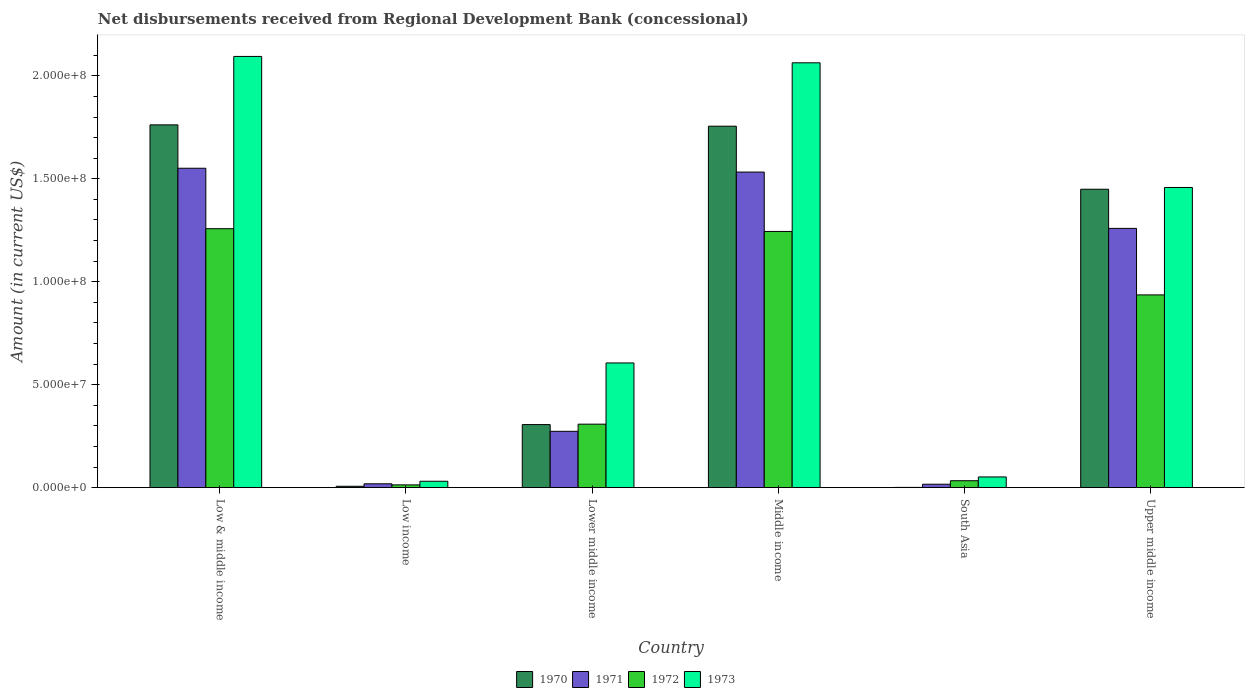How many different coloured bars are there?
Provide a succinct answer. 4. How many groups of bars are there?
Offer a very short reply. 6. How many bars are there on the 5th tick from the left?
Your response must be concise. 4. How many bars are there on the 3rd tick from the right?
Ensure brevity in your answer.  4. What is the label of the 3rd group of bars from the left?
Your answer should be compact. Lower middle income. What is the amount of disbursements received from Regional Development Bank in 1973 in Low & middle income?
Provide a short and direct response. 2.09e+08. Across all countries, what is the maximum amount of disbursements received from Regional Development Bank in 1972?
Ensure brevity in your answer.  1.26e+08. Across all countries, what is the minimum amount of disbursements received from Regional Development Bank in 1970?
Keep it short and to the point. 1.09e+05. In which country was the amount of disbursements received from Regional Development Bank in 1971 maximum?
Offer a terse response. Low & middle income. In which country was the amount of disbursements received from Regional Development Bank in 1973 minimum?
Make the answer very short. Low income. What is the total amount of disbursements received from Regional Development Bank in 1973 in the graph?
Your answer should be compact. 6.30e+08. What is the difference between the amount of disbursements received from Regional Development Bank in 1971 in Middle income and that in Upper middle income?
Keep it short and to the point. 2.74e+07. What is the difference between the amount of disbursements received from Regional Development Bank in 1971 in South Asia and the amount of disbursements received from Regional Development Bank in 1970 in Lower middle income?
Give a very brief answer. -2.90e+07. What is the average amount of disbursements received from Regional Development Bank in 1970 per country?
Offer a terse response. 8.80e+07. What is the difference between the amount of disbursements received from Regional Development Bank of/in 1972 and amount of disbursements received from Regional Development Bank of/in 1973 in Low income?
Your answer should be compact. -1.76e+06. What is the ratio of the amount of disbursements received from Regional Development Bank in 1971 in Lower middle income to that in Upper middle income?
Provide a succinct answer. 0.22. Is the amount of disbursements received from Regional Development Bank in 1970 in Low income less than that in Upper middle income?
Your response must be concise. Yes. What is the difference between the highest and the second highest amount of disbursements received from Regional Development Bank in 1971?
Ensure brevity in your answer.  1.86e+06. What is the difference between the highest and the lowest amount of disbursements received from Regional Development Bank in 1973?
Offer a terse response. 2.06e+08. Is the sum of the amount of disbursements received from Regional Development Bank in 1971 in Low & middle income and Low income greater than the maximum amount of disbursements received from Regional Development Bank in 1972 across all countries?
Give a very brief answer. Yes. Is it the case that in every country, the sum of the amount of disbursements received from Regional Development Bank in 1971 and amount of disbursements received from Regional Development Bank in 1970 is greater than the amount of disbursements received from Regional Development Bank in 1972?
Provide a short and direct response. No. How many bars are there?
Provide a succinct answer. 24. What is the difference between two consecutive major ticks on the Y-axis?
Your answer should be very brief. 5.00e+07. Are the values on the major ticks of Y-axis written in scientific E-notation?
Give a very brief answer. Yes. How are the legend labels stacked?
Your answer should be compact. Horizontal. What is the title of the graph?
Your response must be concise. Net disbursements received from Regional Development Bank (concessional). What is the label or title of the X-axis?
Offer a terse response. Country. What is the label or title of the Y-axis?
Your answer should be compact. Amount (in current US$). What is the Amount (in current US$) of 1970 in Low & middle income?
Ensure brevity in your answer.  1.76e+08. What is the Amount (in current US$) in 1971 in Low & middle income?
Provide a short and direct response. 1.55e+08. What is the Amount (in current US$) in 1972 in Low & middle income?
Offer a very short reply. 1.26e+08. What is the Amount (in current US$) of 1973 in Low & middle income?
Provide a succinct answer. 2.09e+08. What is the Amount (in current US$) in 1970 in Low income?
Ensure brevity in your answer.  6.47e+05. What is the Amount (in current US$) of 1971 in Low income?
Your answer should be compact. 1.86e+06. What is the Amount (in current US$) of 1972 in Low income?
Your response must be concise. 1.33e+06. What is the Amount (in current US$) of 1973 in Low income?
Offer a terse response. 3.09e+06. What is the Amount (in current US$) of 1970 in Lower middle income?
Provide a succinct answer. 3.06e+07. What is the Amount (in current US$) of 1971 in Lower middle income?
Keep it short and to the point. 2.74e+07. What is the Amount (in current US$) in 1972 in Lower middle income?
Give a very brief answer. 3.08e+07. What is the Amount (in current US$) of 1973 in Lower middle income?
Your answer should be very brief. 6.06e+07. What is the Amount (in current US$) in 1970 in Middle income?
Your answer should be compact. 1.76e+08. What is the Amount (in current US$) in 1971 in Middle income?
Provide a succinct answer. 1.53e+08. What is the Amount (in current US$) in 1972 in Middle income?
Provide a short and direct response. 1.24e+08. What is the Amount (in current US$) of 1973 in Middle income?
Your answer should be compact. 2.06e+08. What is the Amount (in current US$) in 1970 in South Asia?
Provide a short and direct response. 1.09e+05. What is the Amount (in current US$) in 1971 in South Asia?
Your answer should be very brief. 1.65e+06. What is the Amount (in current US$) of 1972 in South Asia?
Your answer should be compact. 3.35e+06. What is the Amount (in current US$) of 1973 in South Asia?
Your answer should be compact. 5.18e+06. What is the Amount (in current US$) in 1970 in Upper middle income?
Your response must be concise. 1.45e+08. What is the Amount (in current US$) in 1971 in Upper middle income?
Ensure brevity in your answer.  1.26e+08. What is the Amount (in current US$) of 1972 in Upper middle income?
Your response must be concise. 9.36e+07. What is the Amount (in current US$) in 1973 in Upper middle income?
Provide a short and direct response. 1.46e+08. Across all countries, what is the maximum Amount (in current US$) in 1970?
Keep it short and to the point. 1.76e+08. Across all countries, what is the maximum Amount (in current US$) of 1971?
Your answer should be compact. 1.55e+08. Across all countries, what is the maximum Amount (in current US$) of 1972?
Your answer should be very brief. 1.26e+08. Across all countries, what is the maximum Amount (in current US$) in 1973?
Ensure brevity in your answer.  2.09e+08. Across all countries, what is the minimum Amount (in current US$) in 1970?
Your response must be concise. 1.09e+05. Across all countries, what is the minimum Amount (in current US$) of 1971?
Offer a very short reply. 1.65e+06. Across all countries, what is the minimum Amount (in current US$) of 1972?
Give a very brief answer. 1.33e+06. Across all countries, what is the minimum Amount (in current US$) in 1973?
Provide a succinct answer. 3.09e+06. What is the total Amount (in current US$) of 1970 in the graph?
Keep it short and to the point. 5.28e+08. What is the total Amount (in current US$) in 1971 in the graph?
Provide a short and direct response. 4.65e+08. What is the total Amount (in current US$) of 1972 in the graph?
Provide a succinct answer. 3.79e+08. What is the total Amount (in current US$) of 1973 in the graph?
Ensure brevity in your answer.  6.30e+08. What is the difference between the Amount (in current US$) in 1970 in Low & middle income and that in Low income?
Ensure brevity in your answer.  1.76e+08. What is the difference between the Amount (in current US$) in 1971 in Low & middle income and that in Low income?
Your answer should be compact. 1.53e+08. What is the difference between the Amount (in current US$) of 1972 in Low & middle income and that in Low income?
Keep it short and to the point. 1.24e+08. What is the difference between the Amount (in current US$) of 1973 in Low & middle income and that in Low income?
Your response must be concise. 2.06e+08. What is the difference between the Amount (in current US$) in 1970 in Low & middle income and that in Lower middle income?
Your response must be concise. 1.46e+08. What is the difference between the Amount (in current US$) of 1971 in Low & middle income and that in Lower middle income?
Keep it short and to the point. 1.28e+08. What is the difference between the Amount (in current US$) of 1972 in Low & middle income and that in Lower middle income?
Your answer should be very brief. 9.49e+07. What is the difference between the Amount (in current US$) in 1973 in Low & middle income and that in Lower middle income?
Your answer should be very brief. 1.49e+08. What is the difference between the Amount (in current US$) in 1970 in Low & middle income and that in Middle income?
Offer a terse response. 6.47e+05. What is the difference between the Amount (in current US$) of 1971 in Low & middle income and that in Middle income?
Your answer should be compact. 1.86e+06. What is the difference between the Amount (in current US$) in 1972 in Low & middle income and that in Middle income?
Provide a short and direct response. 1.33e+06. What is the difference between the Amount (in current US$) of 1973 in Low & middle income and that in Middle income?
Make the answer very short. 3.09e+06. What is the difference between the Amount (in current US$) in 1970 in Low & middle income and that in South Asia?
Give a very brief answer. 1.76e+08. What is the difference between the Amount (in current US$) in 1971 in Low & middle income and that in South Asia?
Provide a short and direct response. 1.53e+08. What is the difference between the Amount (in current US$) in 1972 in Low & middle income and that in South Asia?
Your answer should be compact. 1.22e+08. What is the difference between the Amount (in current US$) in 1973 in Low & middle income and that in South Asia?
Your answer should be very brief. 2.04e+08. What is the difference between the Amount (in current US$) in 1970 in Low & middle income and that in Upper middle income?
Provide a succinct answer. 3.13e+07. What is the difference between the Amount (in current US$) in 1971 in Low & middle income and that in Upper middle income?
Give a very brief answer. 2.92e+07. What is the difference between the Amount (in current US$) in 1972 in Low & middle income and that in Upper middle income?
Your response must be concise. 3.22e+07. What is the difference between the Amount (in current US$) of 1973 in Low & middle income and that in Upper middle income?
Ensure brevity in your answer.  6.36e+07. What is the difference between the Amount (in current US$) of 1970 in Low income and that in Lower middle income?
Offer a terse response. -3.00e+07. What is the difference between the Amount (in current US$) in 1971 in Low income and that in Lower middle income?
Provide a succinct answer. -2.55e+07. What is the difference between the Amount (in current US$) in 1972 in Low income and that in Lower middle income?
Provide a succinct answer. -2.95e+07. What is the difference between the Amount (in current US$) of 1973 in Low income and that in Lower middle income?
Give a very brief answer. -5.75e+07. What is the difference between the Amount (in current US$) in 1970 in Low income and that in Middle income?
Make the answer very short. -1.75e+08. What is the difference between the Amount (in current US$) in 1971 in Low income and that in Middle income?
Keep it short and to the point. -1.51e+08. What is the difference between the Amount (in current US$) of 1972 in Low income and that in Middle income?
Give a very brief answer. -1.23e+08. What is the difference between the Amount (in current US$) in 1973 in Low income and that in Middle income?
Offer a very short reply. -2.03e+08. What is the difference between the Amount (in current US$) in 1970 in Low income and that in South Asia?
Offer a very short reply. 5.38e+05. What is the difference between the Amount (in current US$) in 1971 in Low income and that in South Asia?
Provide a succinct answer. 2.09e+05. What is the difference between the Amount (in current US$) in 1972 in Low income and that in South Asia?
Your answer should be compact. -2.02e+06. What is the difference between the Amount (in current US$) of 1973 in Low income and that in South Asia?
Offer a very short reply. -2.09e+06. What is the difference between the Amount (in current US$) of 1970 in Low income and that in Upper middle income?
Offer a terse response. -1.44e+08. What is the difference between the Amount (in current US$) of 1971 in Low income and that in Upper middle income?
Provide a short and direct response. -1.24e+08. What is the difference between the Amount (in current US$) in 1972 in Low income and that in Upper middle income?
Offer a very short reply. -9.23e+07. What is the difference between the Amount (in current US$) of 1973 in Low income and that in Upper middle income?
Provide a succinct answer. -1.43e+08. What is the difference between the Amount (in current US$) in 1970 in Lower middle income and that in Middle income?
Provide a short and direct response. -1.45e+08. What is the difference between the Amount (in current US$) in 1971 in Lower middle income and that in Middle income?
Your answer should be compact. -1.26e+08. What is the difference between the Amount (in current US$) of 1972 in Lower middle income and that in Middle income?
Offer a very short reply. -9.36e+07. What is the difference between the Amount (in current US$) in 1973 in Lower middle income and that in Middle income?
Offer a very short reply. -1.46e+08. What is the difference between the Amount (in current US$) of 1970 in Lower middle income and that in South Asia?
Offer a very short reply. 3.05e+07. What is the difference between the Amount (in current US$) in 1971 in Lower middle income and that in South Asia?
Your answer should be very brief. 2.57e+07. What is the difference between the Amount (in current US$) in 1972 in Lower middle income and that in South Asia?
Your answer should be compact. 2.75e+07. What is the difference between the Amount (in current US$) of 1973 in Lower middle income and that in South Asia?
Make the answer very short. 5.54e+07. What is the difference between the Amount (in current US$) in 1970 in Lower middle income and that in Upper middle income?
Offer a terse response. -1.14e+08. What is the difference between the Amount (in current US$) in 1971 in Lower middle income and that in Upper middle income?
Your answer should be compact. -9.86e+07. What is the difference between the Amount (in current US$) of 1972 in Lower middle income and that in Upper middle income?
Keep it short and to the point. -6.28e+07. What is the difference between the Amount (in current US$) in 1973 in Lower middle income and that in Upper middle income?
Your response must be concise. -8.52e+07. What is the difference between the Amount (in current US$) in 1970 in Middle income and that in South Asia?
Ensure brevity in your answer.  1.75e+08. What is the difference between the Amount (in current US$) in 1971 in Middle income and that in South Asia?
Your answer should be compact. 1.52e+08. What is the difference between the Amount (in current US$) in 1972 in Middle income and that in South Asia?
Your response must be concise. 1.21e+08. What is the difference between the Amount (in current US$) of 1973 in Middle income and that in South Asia?
Your response must be concise. 2.01e+08. What is the difference between the Amount (in current US$) in 1970 in Middle income and that in Upper middle income?
Provide a succinct answer. 3.06e+07. What is the difference between the Amount (in current US$) of 1971 in Middle income and that in Upper middle income?
Provide a short and direct response. 2.74e+07. What is the difference between the Amount (in current US$) of 1972 in Middle income and that in Upper middle income?
Your answer should be compact. 3.08e+07. What is the difference between the Amount (in current US$) of 1973 in Middle income and that in Upper middle income?
Your answer should be very brief. 6.06e+07. What is the difference between the Amount (in current US$) in 1970 in South Asia and that in Upper middle income?
Your response must be concise. -1.45e+08. What is the difference between the Amount (in current US$) of 1971 in South Asia and that in Upper middle income?
Provide a succinct answer. -1.24e+08. What is the difference between the Amount (in current US$) of 1972 in South Asia and that in Upper middle income?
Your response must be concise. -9.03e+07. What is the difference between the Amount (in current US$) of 1973 in South Asia and that in Upper middle income?
Keep it short and to the point. -1.41e+08. What is the difference between the Amount (in current US$) in 1970 in Low & middle income and the Amount (in current US$) in 1971 in Low income?
Provide a succinct answer. 1.74e+08. What is the difference between the Amount (in current US$) in 1970 in Low & middle income and the Amount (in current US$) in 1972 in Low income?
Provide a short and direct response. 1.75e+08. What is the difference between the Amount (in current US$) of 1970 in Low & middle income and the Amount (in current US$) of 1973 in Low income?
Keep it short and to the point. 1.73e+08. What is the difference between the Amount (in current US$) of 1971 in Low & middle income and the Amount (in current US$) of 1972 in Low income?
Your response must be concise. 1.54e+08. What is the difference between the Amount (in current US$) in 1971 in Low & middle income and the Amount (in current US$) in 1973 in Low income?
Provide a short and direct response. 1.52e+08. What is the difference between the Amount (in current US$) of 1972 in Low & middle income and the Amount (in current US$) of 1973 in Low income?
Provide a succinct answer. 1.23e+08. What is the difference between the Amount (in current US$) in 1970 in Low & middle income and the Amount (in current US$) in 1971 in Lower middle income?
Your response must be concise. 1.49e+08. What is the difference between the Amount (in current US$) of 1970 in Low & middle income and the Amount (in current US$) of 1972 in Lower middle income?
Provide a short and direct response. 1.45e+08. What is the difference between the Amount (in current US$) of 1970 in Low & middle income and the Amount (in current US$) of 1973 in Lower middle income?
Make the answer very short. 1.16e+08. What is the difference between the Amount (in current US$) in 1971 in Low & middle income and the Amount (in current US$) in 1972 in Lower middle income?
Offer a terse response. 1.24e+08. What is the difference between the Amount (in current US$) of 1971 in Low & middle income and the Amount (in current US$) of 1973 in Lower middle income?
Offer a terse response. 9.46e+07. What is the difference between the Amount (in current US$) in 1972 in Low & middle income and the Amount (in current US$) in 1973 in Lower middle income?
Ensure brevity in your answer.  6.52e+07. What is the difference between the Amount (in current US$) in 1970 in Low & middle income and the Amount (in current US$) in 1971 in Middle income?
Ensure brevity in your answer.  2.29e+07. What is the difference between the Amount (in current US$) of 1970 in Low & middle income and the Amount (in current US$) of 1972 in Middle income?
Your answer should be very brief. 5.18e+07. What is the difference between the Amount (in current US$) of 1970 in Low & middle income and the Amount (in current US$) of 1973 in Middle income?
Your answer should be very brief. -3.01e+07. What is the difference between the Amount (in current US$) in 1971 in Low & middle income and the Amount (in current US$) in 1972 in Middle income?
Offer a terse response. 3.07e+07. What is the difference between the Amount (in current US$) of 1971 in Low & middle income and the Amount (in current US$) of 1973 in Middle income?
Your response must be concise. -5.12e+07. What is the difference between the Amount (in current US$) in 1972 in Low & middle income and the Amount (in current US$) in 1973 in Middle income?
Your answer should be very brief. -8.06e+07. What is the difference between the Amount (in current US$) in 1970 in Low & middle income and the Amount (in current US$) in 1971 in South Asia?
Ensure brevity in your answer.  1.75e+08. What is the difference between the Amount (in current US$) of 1970 in Low & middle income and the Amount (in current US$) of 1972 in South Asia?
Your answer should be compact. 1.73e+08. What is the difference between the Amount (in current US$) in 1970 in Low & middle income and the Amount (in current US$) in 1973 in South Asia?
Your answer should be very brief. 1.71e+08. What is the difference between the Amount (in current US$) of 1971 in Low & middle income and the Amount (in current US$) of 1972 in South Asia?
Give a very brief answer. 1.52e+08. What is the difference between the Amount (in current US$) of 1971 in Low & middle income and the Amount (in current US$) of 1973 in South Asia?
Provide a short and direct response. 1.50e+08. What is the difference between the Amount (in current US$) in 1972 in Low & middle income and the Amount (in current US$) in 1973 in South Asia?
Provide a succinct answer. 1.21e+08. What is the difference between the Amount (in current US$) of 1970 in Low & middle income and the Amount (in current US$) of 1971 in Upper middle income?
Ensure brevity in your answer.  5.03e+07. What is the difference between the Amount (in current US$) of 1970 in Low & middle income and the Amount (in current US$) of 1972 in Upper middle income?
Offer a terse response. 8.26e+07. What is the difference between the Amount (in current US$) of 1970 in Low & middle income and the Amount (in current US$) of 1973 in Upper middle income?
Give a very brief answer. 3.04e+07. What is the difference between the Amount (in current US$) in 1971 in Low & middle income and the Amount (in current US$) in 1972 in Upper middle income?
Keep it short and to the point. 6.15e+07. What is the difference between the Amount (in current US$) of 1971 in Low & middle income and the Amount (in current US$) of 1973 in Upper middle income?
Your response must be concise. 9.34e+06. What is the difference between the Amount (in current US$) of 1972 in Low & middle income and the Amount (in current US$) of 1973 in Upper middle income?
Give a very brief answer. -2.00e+07. What is the difference between the Amount (in current US$) in 1970 in Low income and the Amount (in current US$) in 1971 in Lower middle income?
Your answer should be very brief. -2.67e+07. What is the difference between the Amount (in current US$) of 1970 in Low income and the Amount (in current US$) of 1972 in Lower middle income?
Make the answer very short. -3.02e+07. What is the difference between the Amount (in current US$) of 1970 in Low income and the Amount (in current US$) of 1973 in Lower middle income?
Offer a terse response. -5.99e+07. What is the difference between the Amount (in current US$) in 1971 in Low income and the Amount (in current US$) in 1972 in Lower middle income?
Your response must be concise. -2.90e+07. What is the difference between the Amount (in current US$) of 1971 in Low income and the Amount (in current US$) of 1973 in Lower middle income?
Give a very brief answer. -5.87e+07. What is the difference between the Amount (in current US$) in 1972 in Low income and the Amount (in current US$) in 1973 in Lower middle income?
Your answer should be compact. -5.92e+07. What is the difference between the Amount (in current US$) of 1970 in Low income and the Amount (in current US$) of 1971 in Middle income?
Give a very brief answer. -1.53e+08. What is the difference between the Amount (in current US$) of 1970 in Low income and the Amount (in current US$) of 1972 in Middle income?
Give a very brief answer. -1.24e+08. What is the difference between the Amount (in current US$) in 1970 in Low income and the Amount (in current US$) in 1973 in Middle income?
Provide a short and direct response. -2.06e+08. What is the difference between the Amount (in current US$) of 1971 in Low income and the Amount (in current US$) of 1972 in Middle income?
Keep it short and to the point. -1.23e+08. What is the difference between the Amount (in current US$) in 1971 in Low income and the Amount (in current US$) in 1973 in Middle income?
Your response must be concise. -2.04e+08. What is the difference between the Amount (in current US$) in 1972 in Low income and the Amount (in current US$) in 1973 in Middle income?
Make the answer very short. -2.05e+08. What is the difference between the Amount (in current US$) of 1970 in Low income and the Amount (in current US$) of 1971 in South Asia?
Your response must be concise. -1.00e+06. What is the difference between the Amount (in current US$) in 1970 in Low income and the Amount (in current US$) in 1972 in South Asia?
Your response must be concise. -2.70e+06. What is the difference between the Amount (in current US$) of 1970 in Low income and the Amount (in current US$) of 1973 in South Asia?
Provide a short and direct response. -4.54e+06. What is the difference between the Amount (in current US$) in 1971 in Low income and the Amount (in current US$) in 1972 in South Asia?
Give a very brief answer. -1.49e+06. What is the difference between the Amount (in current US$) of 1971 in Low income and the Amount (in current US$) of 1973 in South Asia?
Offer a very short reply. -3.32e+06. What is the difference between the Amount (in current US$) in 1972 in Low income and the Amount (in current US$) in 1973 in South Asia?
Provide a short and direct response. -3.85e+06. What is the difference between the Amount (in current US$) in 1970 in Low income and the Amount (in current US$) in 1971 in Upper middle income?
Your response must be concise. -1.25e+08. What is the difference between the Amount (in current US$) in 1970 in Low income and the Amount (in current US$) in 1972 in Upper middle income?
Provide a short and direct response. -9.30e+07. What is the difference between the Amount (in current US$) in 1970 in Low income and the Amount (in current US$) in 1973 in Upper middle income?
Offer a terse response. -1.45e+08. What is the difference between the Amount (in current US$) of 1971 in Low income and the Amount (in current US$) of 1972 in Upper middle income?
Ensure brevity in your answer.  -9.17e+07. What is the difference between the Amount (in current US$) of 1971 in Low income and the Amount (in current US$) of 1973 in Upper middle income?
Keep it short and to the point. -1.44e+08. What is the difference between the Amount (in current US$) in 1972 in Low income and the Amount (in current US$) in 1973 in Upper middle income?
Offer a terse response. -1.44e+08. What is the difference between the Amount (in current US$) in 1970 in Lower middle income and the Amount (in current US$) in 1971 in Middle income?
Provide a succinct answer. -1.23e+08. What is the difference between the Amount (in current US$) of 1970 in Lower middle income and the Amount (in current US$) of 1972 in Middle income?
Your answer should be very brief. -9.38e+07. What is the difference between the Amount (in current US$) of 1970 in Lower middle income and the Amount (in current US$) of 1973 in Middle income?
Keep it short and to the point. -1.76e+08. What is the difference between the Amount (in current US$) of 1971 in Lower middle income and the Amount (in current US$) of 1972 in Middle income?
Offer a terse response. -9.71e+07. What is the difference between the Amount (in current US$) in 1971 in Lower middle income and the Amount (in current US$) in 1973 in Middle income?
Give a very brief answer. -1.79e+08. What is the difference between the Amount (in current US$) of 1972 in Lower middle income and the Amount (in current US$) of 1973 in Middle income?
Keep it short and to the point. -1.76e+08. What is the difference between the Amount (in current US$) of 1970 in Lower middle income and the Amount (in current US$) of 1971 in South Asia?
Your answer should be very brief. 2.90e+07. What is the difference between the Amount (in current US$) of 1970 in Lower middle income and the Amount (in current US$) of 1972 in South Asia?
Give a very brief answer. 2.73e+07. What is the difference between the Amount (in current US$) of 1970 in Lower middle income and the Amount (in current US$) of 1973 in South Asia?
Your response must be concise. 2.54e+07. What is the difference between the Amount (in current US$) in 1971 in Lower middle income and the Amount (in current US$) in 1972 in South Asia?
Offer a terse response. 2.40e+07. What is the difference between the Amount (in current US$) of 1971 in Lower middle income and the Amount (in current US$) of 1973 in South Asia?
Keep it short and to the point. 2.22e+07. What is the difference between the Amount (in current US$) of 1972 in Lower middle income and the Amount (in current US$) of 1973 in South Asia?
Offer a very short reply. 2.56e+07. What is the difference between the Amount (in current US$) in 1970 in Lower middle income and the Amount (in current US$) in 1971 in Upper middle income?
Provide a succinct answer. -9.53e+07. What is the difference between the Amount (in current US$) of 1970 in Lower middle income and the Amount (in current US$) of 1972 in Upper middle income?
Keep it short and to the point. -6.30e+07. What is the difference between the Amount (in current US$) of 1970 in Lower middle income and the Amount (in current US$) of 1973 in Upper middle income?
Give a very brief answer. -1.15e+08. What is the difference between the Amount (in current US$) in 1971 in Lower middle income and the Amount (in current US$) in 1972 in Upper middle income?
Your response must be concise. -6.63e+07. What is the difference between the Amount (in current US$) of 1971 in Lower middle income and the Amount (in current US$) of 1973 in Upper middle income?
Ensure brevity in your answer.  -1.18e+08. What is the difference between the Amount (in current US$) of 1972 in Lower middle income and the Amount (in current US$) of 1973 in Upper middle income?
Keep it short and to the point. -1.15e+08. What is the difference between the Amount (in current US$) in 1970 in Middle income and the Amount (in current US$) in 1971 in South Asia?
Keep it short and to the point. 1.74e+08. What is the difference between the Amount (in current US$) of 1970 in Middle income and the Amount (in current US$) of 1972 in South Asia?
Make the answer very short. 1.72e+08. What is the difference between the Amount (in current US$) of 1970 in Middle income and the Amount (in current US$) of 1973 in South Asia?
Your answer should be very brief. 1.70e+08. What is the difference between the Amount (in current US$) of 1971 in Middle income and the Amount (in current US$) of 1972 in South Asia?
Ensure brevity in your answer.  1.50e+08. What is the difference between the Amount (in current US$) in 1971 in Middle income and the Amount (in current US$) in 1973 in South Asia?
Keep it short and to the point. 1.48e+08. What is the difference between the Amount (in current US$) in 1972 in Middle income and the Amount (in current US$) in 1973 in South Asia?
Your answer should be compact. 1.19e+08. What is the difference between the Amount (in current US$) in 1970 in Middle income and the Amount (in current US$) in 1971 in Upper middle income?
Provide a succinct answer. 4.96e+07. What is the difference between the Amount (in current US$) of 1970 in Middle income and the Amount (in current US$) of 1972 in Upper middle income?
Offer a terse response. 8.19e+07. What is the difference between the Amount (in current US$) of 1970 in Middle income and the Amount (in current US$) of 1973 in Upper middle income?
Provide a succinct answer. 2.98e+07. What is the difference between the Amount (in current US$) in 1971 in Middle income and the Amount (in current US$) in 1972 in Upper middle income?
Provide a succinct answer. 5.97e+07. What is the difference between the Amount (in current US$) of 1971 in Middle income and the Amount (in current US$) of 1973 in Upper middle income?
Offer a terse response. 7.49e+06. What is the difference between the Amount (in current US$) in 1972 in Middle income and the Amount (in current US$) in 1973 in Upper middle income?
Ensure brevity in your answer.  -2.14e+07. What is the difference between the Amount (in current US$) in 1970 in South Asia and the Amount (in current US$) in 1971 in Upper middle income?
Offer a terse response. -1.26e+08. What is the difference between the Amount (in current US$) of 1970 in South Asia and the Amount (in current US$) of 1972 in Upper middle income?
Your response must be concise. -9.35e+07. What is the difference between the Amount (in current US$) in 1970 in South Asia and the Amount (in current US$) in 1973 in Upper middle income?
Offer a very short reply. -1.46e+08. What is the difference between the Amount (in current US$) in 1971 in South Asia and the Amount (in current US$) in 1972 in Upper middle income?
Make the answer very short. -9.20e+07. What is the difference between the Amount (in current US$) in 1971 in South Asia and the Amount (in current US$) in 1973 in Upper middle income?
Your answer should be very brief. -1.44e+08. What is the difference between the Amount (in current US$) of 1972 in South Asia and the Amount (in current US$) of 1973 in Upper middle income?
Provide a short and direct response. -1.42e+08. What is the average Amount (in current US$) of 1970 per country?
Ensure brevity in your answer.  8.80e+07. What is the average Amount (in current US$) in 1971 per country?
Keep it short and to the point. 7.75e+07. What is the average Amount (in current US$) of 1972 per country?
Your answer should be compact. 6.32e+07. What is the average Amount (in current US$) in 1973 per country?
Offer a terse response. 1.05e+08. What is the difference between the Amount (in current US$) in 1970 and Amount (in current US$) in 1971 in Low & middle income?
Give a very brief answer. 2.11e+07. What is the difference between the Amount (in current US$) in 1970 and Amount (in current US$) in 1972 in Low & middle income?
Offer a terse response. 5.04e+07. What is the difference between the Amount (in current US$) of 1970 and Amount (in current US$) of 1973 in Low & middle income?
Offer a terse response. -3.32e+07. What is the difference between the Amount (in current US$) of 1971 and Amount (in current US$) of 1972 in Low & middle income?
Make the answer very short. 2.94e+07. What is the difference between the Amount (in current US$) of 1971 and Amount (in current US$) of 1973 in Low & middle income?
Provide a short and direct response. -5.43e+07. What is the difference between the Amount (in current US$) of 1972 and Amount (in current US$) of 1973 in Low & middle income?
Your answer should be compact. -8.37e+07. What is the difference between the Amount (in current US$) in 1970 and Amount (in current US$) in 1971 in Low income?
Provide a short and direct response. -1.21e+06. What is the difference between the Amount (in current US$) in 1970 and Amount (in current US$) in 1972 in Low income?
Ensure brevity in your answer.  -6.86e+05. What is the difference between the Amount (in current US$) of 1970 and Amount (in current US$) of 1973 in Low income?
Your answer should be compact. -2.44e+06. What is the difference between the Amount (in current US$) in 1971 and Amount (in current US$) in 1972 in Low income?
Your answer should be compact. 5.26e+05. What is the difference between the Amount (in current US$) in 1971 and Amount (in current US$) in 1973 in Low income?
Provide a succinct answer. -1.23e+06. What is the difference between the Amount (in current US$) of 1972 and Amount (in current US$) of 1973 in Low income?
Provide a short and direct response. -1.76e+06. What is the difference between the Amount (in current US$) of 1970 and Amount (in current US$) of 1971 in Lower middle income?
Keep it short and to the point. 3.27e+06. What is the difference between the Amount (in current US$) of 1970 and Amount (in current US$) of 1972 in Lower middle income?
Your answer should be very brief. -2.02e+05. What is the difference between the Amount (in current US$) in 1970 and Amount (in current US$) in 1973 in Lower middle income?
Your response must be concise. -2.99e+07. What is the difference between the Amount (in current US$) of 1971 and Amount (in current US$) of 1972 in Lower middle income?
Your answer should be compact. -3.47e+06. What is the difference between the Amount (in current US$) in 1971 and Amount (in current US$) in 1973 in Lower middle income?
Offer a terse response. -3.32e+07. What is the difference between the Amount (in current US$) in 1972 and Amount (in current US$) in 1973 in Lower middle income?
Your response must be concise. -2.97e+07. What is the difference between the Amount (in current US$) in 1970 and Amount (in current US$) in 1971 in Middle income?
Make the answer very short. 2.23e+07. What is the difference between the Amount (in current US$) in 1970 and Amount (in current US$) in 1972 in Middle income?
Offer a terse response. 5.11e+07. What is the difference between the Amount (in current US$) in 1970 and Amount (in current US$) in 1973 in Middle income?
Offer a terse response. -3.08e+07. What is the difference between the Amount (in current US$) of 1971 and Amount (in current US$) of 1972 in Middle income?
Ensure brevity in your answer.  2.88e+07. What is the difference between the Amount (in current US$) of 1971 and Amount (in current US$) of 1973 in Middle income?
Offer a terse response. -5.31e+07. What is the difference between the Amount (in current US$) of 1972 and Amount (in current US$) of 1973 in Middle income?
Provide a short and direct response. -8.19e+07. What is the difference between the Amount (in current US$) of 1970 and Amount (in current US$) of 1971 in South Asia?
Your answer should be very brief. -1.54e+06. What is the difference between the Amount (in current US$) in 1970 and Amount (in current US$) in 1972 in South Asia?
Ensure brevity in your answer.  -3.24e+06. What is the difference between the Amount (in current US$) in 1970 and Amount (in current US$) in 1973 in South Asia?
Make the answer very short. -5.08e+06. What is the difference between the Amount (in current US$) in 1971 and Amount (in current US$) in 1972 in South Asia?
Ensure brevity in your answer.  -1.70e+06. What is the difference between the Amount (in current US$) of 1971 and Amount (in current US$) of 1973 in South Asia?
Ensure brevity in your answer.  -3.53e+06. What is the difference between the Amount (in current US$) in 1972 and Amount (in current US$) in 1973 in South Asia?
Provide a short and direct response. -1.83e+06. What is the difference between the Amount (in current US$) of 1970 and Amount (in current US$) of 1971 in Upper middle income?
Keep it short and to the point. 1.90e+07. What is the difference between the Amount (in current US$) of 1970 and Amount (in current US$) of 1972 in Upper middle income?
Offer a very short reply. 5.13e+07. What is the difference between the Amount (in current US$) in 1970 and Amount (in current US$) in 1973 in Upper middle income?
Make the answer very short. -8.58e+05. What is the difference between the Amount (in current US$) of 1971 and Amount (in current US$) of 1972 in Upper middle income?
Make the answer very short. 3.23e+07. What is the difference between the Amount (in current US$) in 1971 and Amount (in current US$) in 1973 in Upper middle income?
Your answer should be compact. -1.99e+07. What is the difference between the Amount (in current US$) in 1972 and Amount (in current US$) in 1973 in Upper middle income?
Offer a very short reply. -5.22e+07. What is the ratio of the Amount (in current US$) of 1970 in Low & middle income to that in Low income?
Provide a succinct answer. 272.33. What is the ratio of the Amount (in current US$) in 1971 in Low & middle income to that in Low income?
Provide a succinct answer. 83.45. What is the ratio of the Amount (in current US$) in 1972 in Low & middle income to that in Low income?
Provide a short and direct response. 94.35. What is the ratio of the Amount (in current US$) of 1973 in Low & middle income to that in Low income?
Provide a short and direct response. 67.76. What is the ratio of the Amount (in current US$) in 1970 in Low & middle income to that in Lower middle income?
Your response must be concise. 5.75. What is the ratio of the Amount (in current US$) in 1971 in Low & middle income to that in Lower middle income?
Provide a short and direct response. 5.67. What is the ratio of the Amount (in current US$) of 1972 in Low & middle income to that in Lower middle income?
Provide a short and direct response. 4.08. What is the ratio of the Amount (in current US$) in 1973 in Low & middle income to that in Lower middle income?
Give a very brief answer. 3.46. What is the ratio of the Amount (in current US$) in 1971 in Low & middle income to that in Middle income?
Ensure brevity in your answer.  1.01. What is the ratio of the Amount (in current US$) of 1972 in Low & middle income to that in Middle income?
Provide a short and direct response. 1.01. What is the ratio of the Amount (in current US$) in 1973 in Low & middle income to that in Middle income?
Your response must be concise. 1.01. What is the ratio of the Amount (in current US$) in 1970 in Low & middle income to that in South Asia?
Make the answer very short. 1616.51. What is the ratio of the Amount (in current US$) of 1971 in Low & middle income to that in South Asia?
Make the answer very short. 94.02. What is the ratio of the Amount (in current US$) in 1972 in Low & middle income to that in South Asia?
Give a very brief answer. 37.54. What is the ratio of the Amount (in current US$) of 1973 in Low & middle income to that in South Asia?
Keep it short and to the point. 40.4. What is the ratio of the Amount (in current US$) in 1970 in Low & middle income to that in Upper middle income?
Keep it short and to the point. 1.22. What is the ratio of the Amount (in current US$) of 1971 in Low & middle income to that in Upper middle income?
Offer a very short reply. 1.23. What is the ratio of the Amount (in current US$) in 1972 in Low & middle income to that in Upper middle income?
Offer a terse response. 1.34. What is the ratio of the Amount (in current US$) in 1973 in Low & middle income to that in Upper middle income?
Your response must be concise. 1.44. What is the ratio of the Amount (in current US$) of 1970 in Low income to that in Lower middle income?
Keep it short and to the point. 0.02. What is the ratio of the Amount (in current US$) in 1971 in Low income to that in Lower middle income?
Give a very brief answer. 0.07. What is the ratio of the Amount (in current US$) of 1972 in Low income to that in Lower middle income?
Your answer should be very brief. 0.04. What is the ratio of the Amount (in current US$) in 1973 in Low income to that in Lower middle income?
Your response must be concise. 0.05. What is the ratio of the Amount (in current US$) in 1970 in Low income to that in Middle income?
Make the answer very short. 0. What is the ratio of the Amount (in current US$) of 1971 in Low income to that in Middle income?
Your answer should be compact. 0.01. What is the ratio of the Amount (in current US$) of 1972 in Low income to that in Middle income?
Your answer should be compact. 0.01. What is the ratio of the Amount (in current US$) in 1973 in Low income to that in Middle income?
Offer a terse response. 0.01. What is the ratio of the Amount (in current US$) of 1970 in Low income to that in South Asia?
Ensure brevity in your answer.  5.94. What is the ratio of the Amount (in current US$) in 1971 in Low income to that in South Asia?
Provide a short and direct response. 1.13. What is the ratio of the Amount (in current US$) of 1972 in Low income to that in South Asia?
Give a very brief answer. 0.4. What is the ratio of the Amount (in current US$) in 1973 in Low income to that in South Asia?
Keep it short and to the point. 0.6. What is the ratio of the Amount (in current US$) in 1970 in Low income to that in Upper middle income?
Provide a short and direct response. 0. What is the ratio of the Amount (in current US$) in 1971 in Low income to that in Upper middle income?
Your answer should be compact. 0.01. What is the ratio of the Amount (in current US$) in 1972 in Low income to that in Upper middle income?
Offer a terse response. 0.01. What is the ratio of the Amount (in current US$) of 1973 in Low income to that in Upper middle income?
Your answer should be very brief. 0.02. What is the ratio of the Amount (in current US$) of 1970 in Lower middle income to that in Middle income?
Your response must be concise. 0.17. What is the ratio of the Amount (in current US$) of 1971 in Lower middle income to that in Middle income?
Keep it short and to the point. 0.18. What is the ratio of the Amount (in current US$) of 1972 in Lower middle income to that in Middle income?
Your answer should be compact. 0.25. What is the ratio of the Amount (in current US$) in 1973 in Lower middle income to that in Middle income?
Provide a short and direct response. 0.29. What is the ratio of the Amount (in current US$) of 1970 in Lower middle income to that in South Asia?
Ensure brevity in your answer.  280.94. What is the ratio of the Amount (in current US$) in 1971 in Lower middle income to that in South Asia?
Your answer should be very brief. 16.58. What is the ratio of the Amount (in current US$) of 1972 in Lower middle income to that in South Asia?
Give a very brief answer. 9.2. What is the ratio of the Amount (in current US$) of 1973 in Lower middle income to that in South Asia?
Your answer should be compact. 11.68. What is the ratio of the Amount (in current US$) of 1970 in Lower middle income to that in Upper middle income?
Provide a short and direct response. 0.21. What is the ratio of the Amount (in current US$) of 1971 in Lower middle income to that in Upper middle income?
Your answer should be compact. 0.22. What is the ratio of the Amount (in current US$) of 1972 in Lower middle income to that in Upper middle income?
Provide a short and direct response. 0.33. What is the ratio of the Amount (in current US$) in 1973 in Lower middle income to that in Upper middle income?
Give a very brief answer. 0.42. What is the ratio of the Amount (in current US$) of 1970 in Middle income to that in South Asia?
Your response must be concise. 1610.58. What is the ratio of the Amount (in current US$) in 1971 in Middle income to that in South Asia?
Provide a succinct answer. 92.89. What is the ratio of the Amount (in current US$) in 1972 in Middle income to that in South Asia?
Provide a short and direct response. 37.14. What is the ratio of the Amount (in current US$) of 1973 in Middle income to that in South Asia?
Keep it short and to the point. 39.8. What is the ratio of the Amount (in current US$) of 1970 in Middle income to that in Upper middle income?
Offer a very short reply. 1.21. What is the ratio of the Amount (in current US$) of 1971 in Middle income to that in Upper middle income?
Make the answer very short. 1.22. What is the ratio of the Amount (in current US$) of 1972 in Middle income to that in Upper middle income?
Offer a very short reply. 1.33. What is the ratio of the Amount (in current US$) of 1973 in Middle income to that in Upper middle income?
Keep it short and to the point. 1.42. What is the ratio of the Amount (in current US$) in 1970 in South Asia to that in Upper middle income?
Your answer should be compact. 0. What is the ratio of the Amount (in current US$) in 1971 in South Asia to that in Upper middle income?
Ensure brevity in your answer.  0.01. What is the ratio of the Amount (in current US$) in 1972 in South Asia to that in Upper middle income?
Your answer should be very brief. 0.04. What is the ratio of the Amount (in current US$) in 1973 in South Asia to that in Upper middle income?
Provide a short and direct response. 0.04. What is the difference between the highest and the second highest Amount (in current US$) in 1970?
Offer a terse response. 6.47e+05. What is the difference between the highest and the second highest Amount (in current US$) in 1971?
Offer a very short reply. 1.86e+06. What is the difference between the highest and the second highest Amount (in current US$) of 1972?
Ensure brevity in your answer.  1.33e+06. What is the difference between the highest and the second highest Amount (in current US$) in 1973?
Offer a very short reply. 3.09e+06. What is the difference between the highest and the lowest Amount (in current US$) in 1970?
Your answer should be very brief. 1.76e+08. What is the difference between the highest and the lowest Amount (in current US$) of 1971?
Offer a terse response. 1.53e+08. What is the difference between the highest and the lowest Amount (in current US$) in 1972?
Your answer should be compact. 1.24e+08. What is the difference between the highest and the lowest Amount (in current US$) in 1973?
Provide a short and direct response. 2.06e+08. 